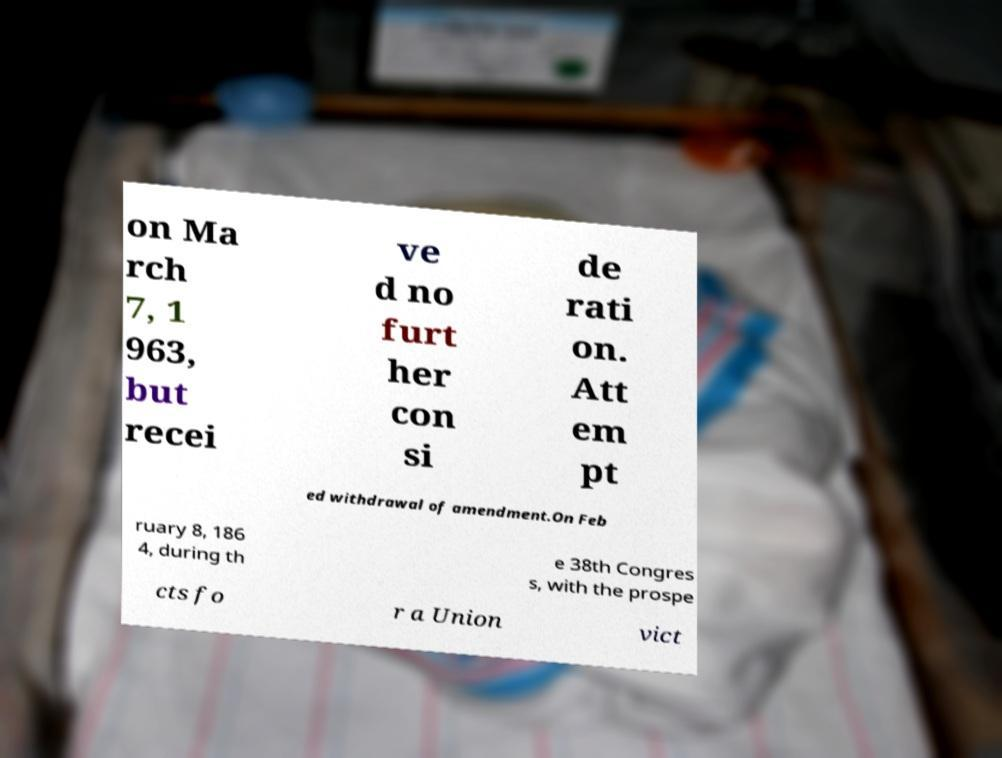For documentation purposes, I need the text within this image transcribed. Could you provide that? on Ma rch 7, 1 963, but recei ve d no furt her con si de rati on. Att em pt ed withdrawal of amendment.On Feb ruary 8, 186 4, during th e 38th Congres s, with the prospe cts fo r a Union vict 